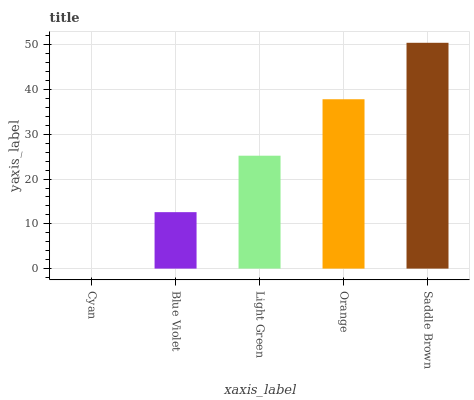Is Cyan the minimum?
Answer yes or no. Yes. Is Saddle Brown the maximum?
Answer yes or no. Yes. Is Blue Violet the minimum?
Answer yes or no. No. Is Blue Violet the maximum?
Answer yes or no. No. Is Blue Violet greater than Cyan?
Answer yes or no. Yes. Is Cyan less than Blue Violet?
Answer yes or no. Yes. Is Cyan greater than Blue Violet?
Answer yes or no. No. Is Blue Violet less than Cyan?
Answer yes or no. No. Is Light Green the high median?
Answer yes or no. Yes. Is Light Green the low median?
Answer yes or no. Yes. Is Cyan the high median?
Answer yes or no. No. Is Blue Violet the low median?
Answer yes or no. No. 